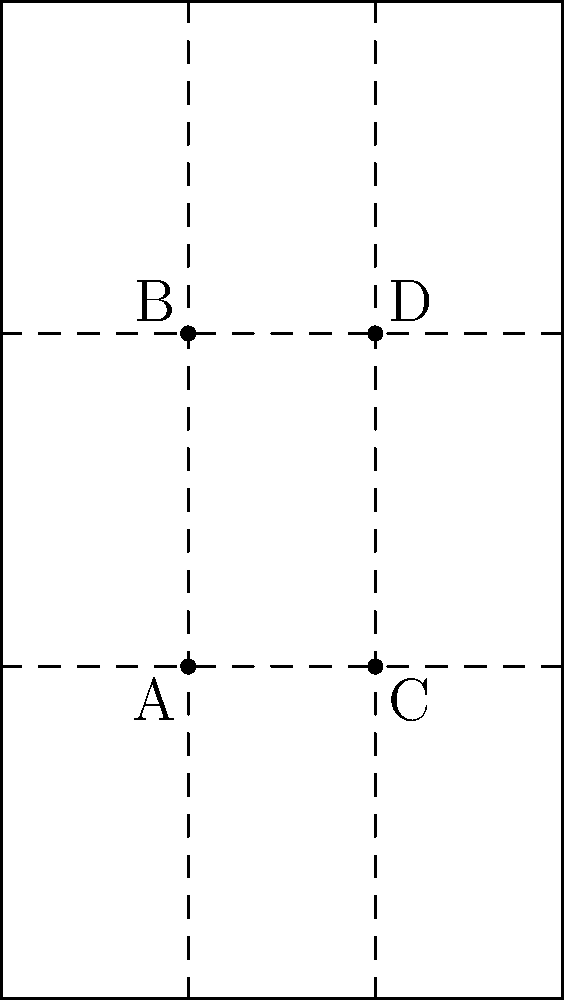In the composition of a film frame using the rule of thirds, how many points of interest are created by the intersection of the grid lines? Identify these points in the diagram above. To understand the rule of thirds and its application in film composition, let's break it down step-by-step:

1. The rule of thirds divides the frame into a 3x3 grid, creating nine equal parts.

2. This is achieved by drawing two equally spaced horizontal lines and two equally spaced vertical lines across the frame.

3. The intersections of these lines create four distinct points within the frame.

4. In the diagram:
   - Point A is located at the intersection of the left vertical line and the lower horizontal line.
   - Point B is at the intersection of the left vertical line and the upper horizontal line.
   - Point C is at the intersection of the right vertical line and the lower horizontal line.
   - Point D is at the intersection of the right vertical line and the upper horizontal line.

5. These four points are considered optimal positions for placing key elements or subjects within the frame to create a visually appealing and balanced composition.

6. In screenwriting and cinematography, understanding these points helps in crafting scenes that are visually engaging and in directing the audience's attention to specific areas of the frame.

Therefore, the rule of thirds creates four points of interest in a film frame, represented by points A, B, C, and D in the diagram.
Answer: 4 points (A, B, C, D) 